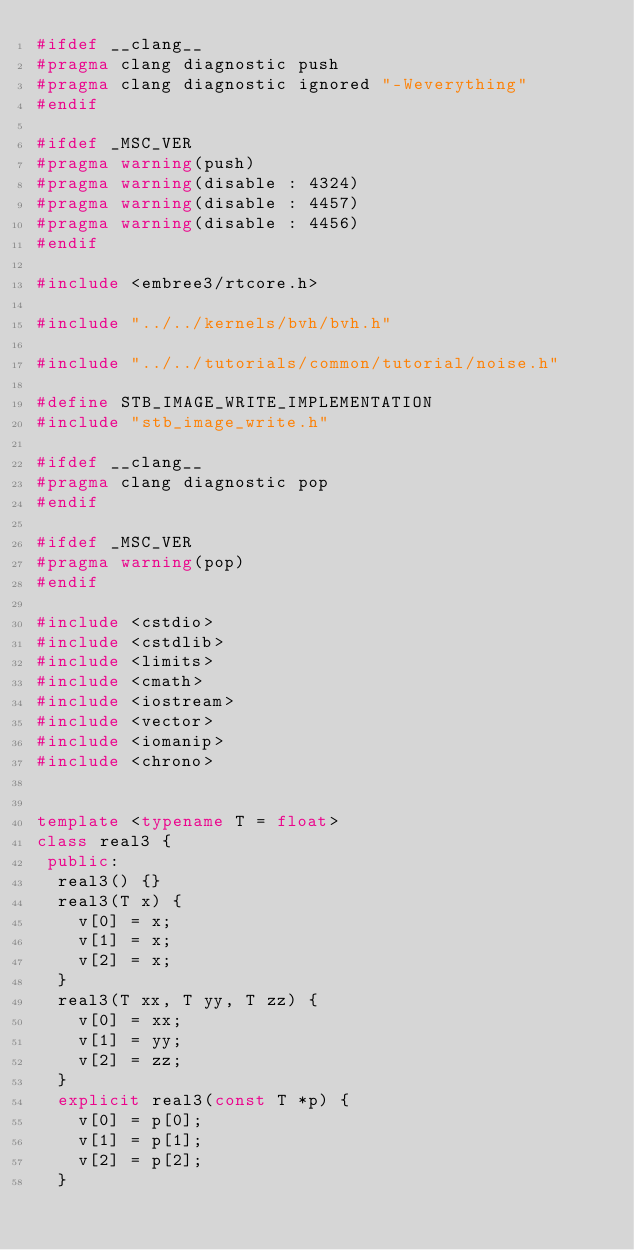<code> <loc_0><loc_0><loc_500><loc_500><_C++_>#ifdef __clang__
#pragma clang diagnostic push
#pragma clang diagnostic ignored "-Weverything"
#endif

#ifdef _MSC_VER
#pragma warning(push)
#pragma warning(disable : 4324)
#pragma warning(disable : 4457)
#pragma warning(disable : 4456)
#endif

#include <embree3/rtcore.h>

#include "../../kernels/bvh/bvh.h"

#include "../../tutorials/common/tutorial/noise.h"

#define STB_IMAGE_WRITE_IMPLEMENTATION
#include "stb_image_write.h"

#ifdef __clang__
#pragma clang diagnostic pop
#endif

#ifdef _MSC_VER
#pragma warning(pop)
#endif

#include <cstdio>
#include <cstdlib>
#include <limits>
#include <cmath>
#include <iostream>
#include <vector>
#include <iomanip>
#include <chrono>


template <typename T = float>
class real3 {
 public:
  real3() {}
  real3(T x) {
    v[0] = x;
    v[1] = x;
    v[2] = x;
  }
  real3(T xx, T yy, T zz) {
    v[0] = xx;
    v[1] = yy;
    v[2] = zz;
  }
  explicit real3(const T *p) {
    v[0] = p[0];
    v[1] = p[1];
    v[2] = p[2];
  }
</code> 